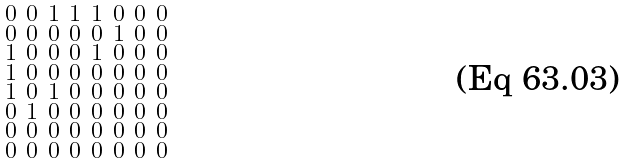<formula> <loc_0><loc_0><loc_500><loc_500>\begin{smallmatrix} 0 & 0 & 1 & 1 & 1 & 0 & 0 & 0 \\ 0 & 0 & 0 & 0 & 0 & 1 & 0 & 0 \\ 1 & 0 & 0 & 0 & 1 & 0 & 0 & 0 \\ 1 & 0 & 0 & 0 & 0 & 0 & 0 & 0 \\ 1 & 0 & 1 & 0 & 0 & 0 & 0 & 0 \\ 0 & 1 & 0 & 0 & 0 & 0 & 0 & 0 \\ 0 & 0 & 0 & 0 & 0 & 0 & 0 & 0 \\ 0 & 0 & 0 & 0 & 0 & 0 & 0 & 0 \end{smallmatrix}</formula> 